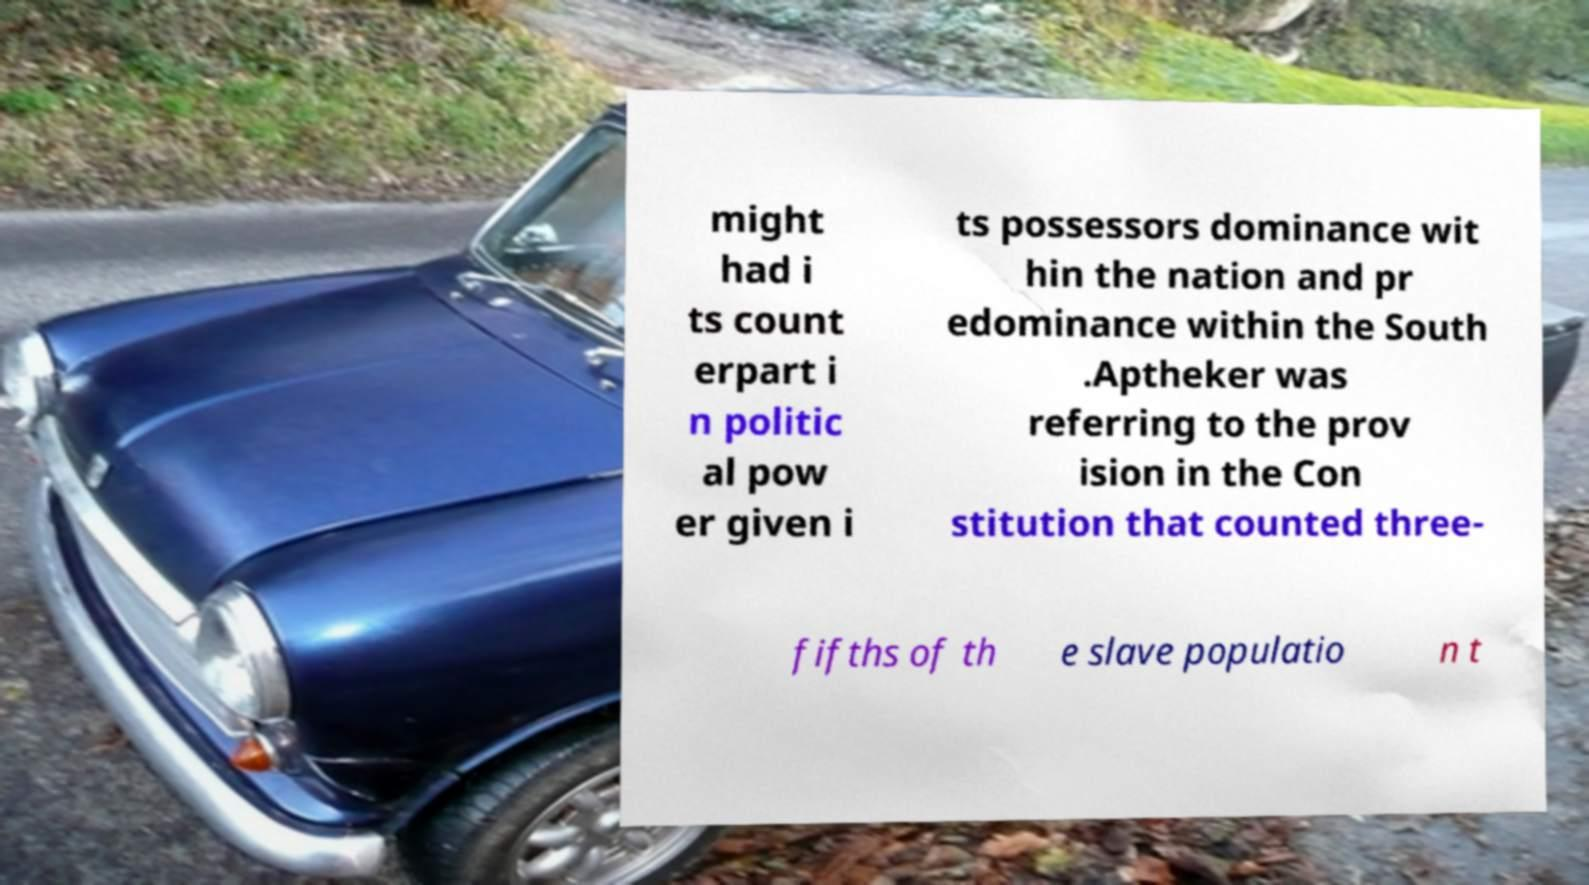Could you extract and type out the text from this image? might had i ts count erpart i n politic al pow er given i ts possessors dominance wit hin the nation and pr edominance within the South .Aptheker was referring to the prov ision in the Con stitution that counted three- fifths of th e slave populatio n t 